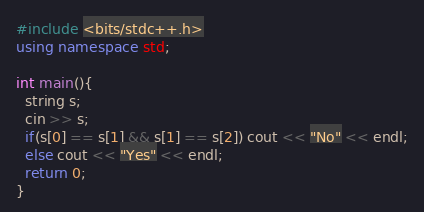<code> <loc_0><loc_0><loc_500><loc_500><_C++_>#include <bits/stdc++.h>
using namespace std;

int main(){
  string s;
  cin >> s;
  if(s[0] == s[1] && s[1] == s[2]) cout << "No" << endl;
  else cout << "Yes" << endl;
  return 0;
}</code> 